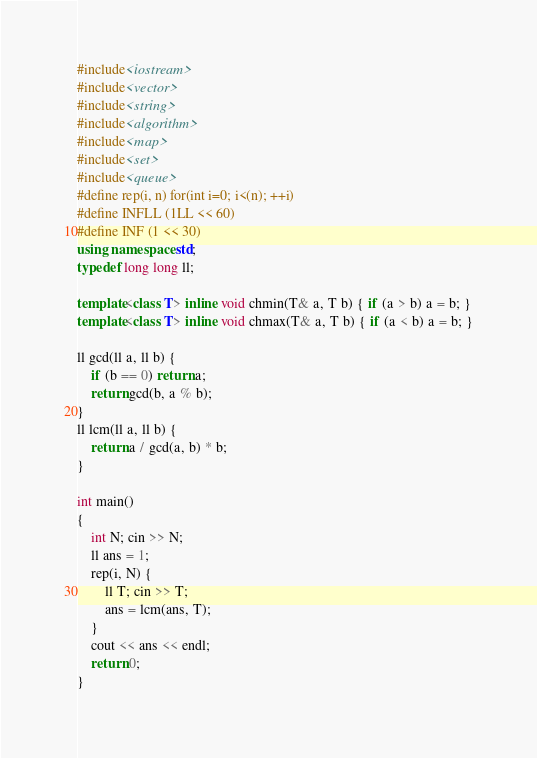Convert code to text. <code><loc_0><loc_0><loc_500><loc_500><_C++_>#include<iostream>
#include<vector>
#include<string>
#include<algorithm>
#include<map>
#include<set>
#include<queue>
#define rep(i, n) for(int i=0; i<(n); ++i)
#define INFLL (1LL << 60)
#define INF (1 << 30)
using namespace std;
typedef long long ll;

template<class T> inline void chmin(T& a, T b) { if (a > b) a = b; }
template<class T> inline void chmax(T& a, T b) { if (a < b) a = b; }

ll gcd(ll a, ll b) {
	if (b == 0) return a;
	return gcd(b, a % b);
}
ll lcm(ll a, ll b) {
	return a / gcd(a, b) * b;
}

int main()
{
	int N; cin >> N;
	ll ans = 1;
	rep(i, N) {
		ll T; cin >> T;
		ans = lcm(ans, T);
	}
	cout << ans << endl;
	return 0;
}
</code> 